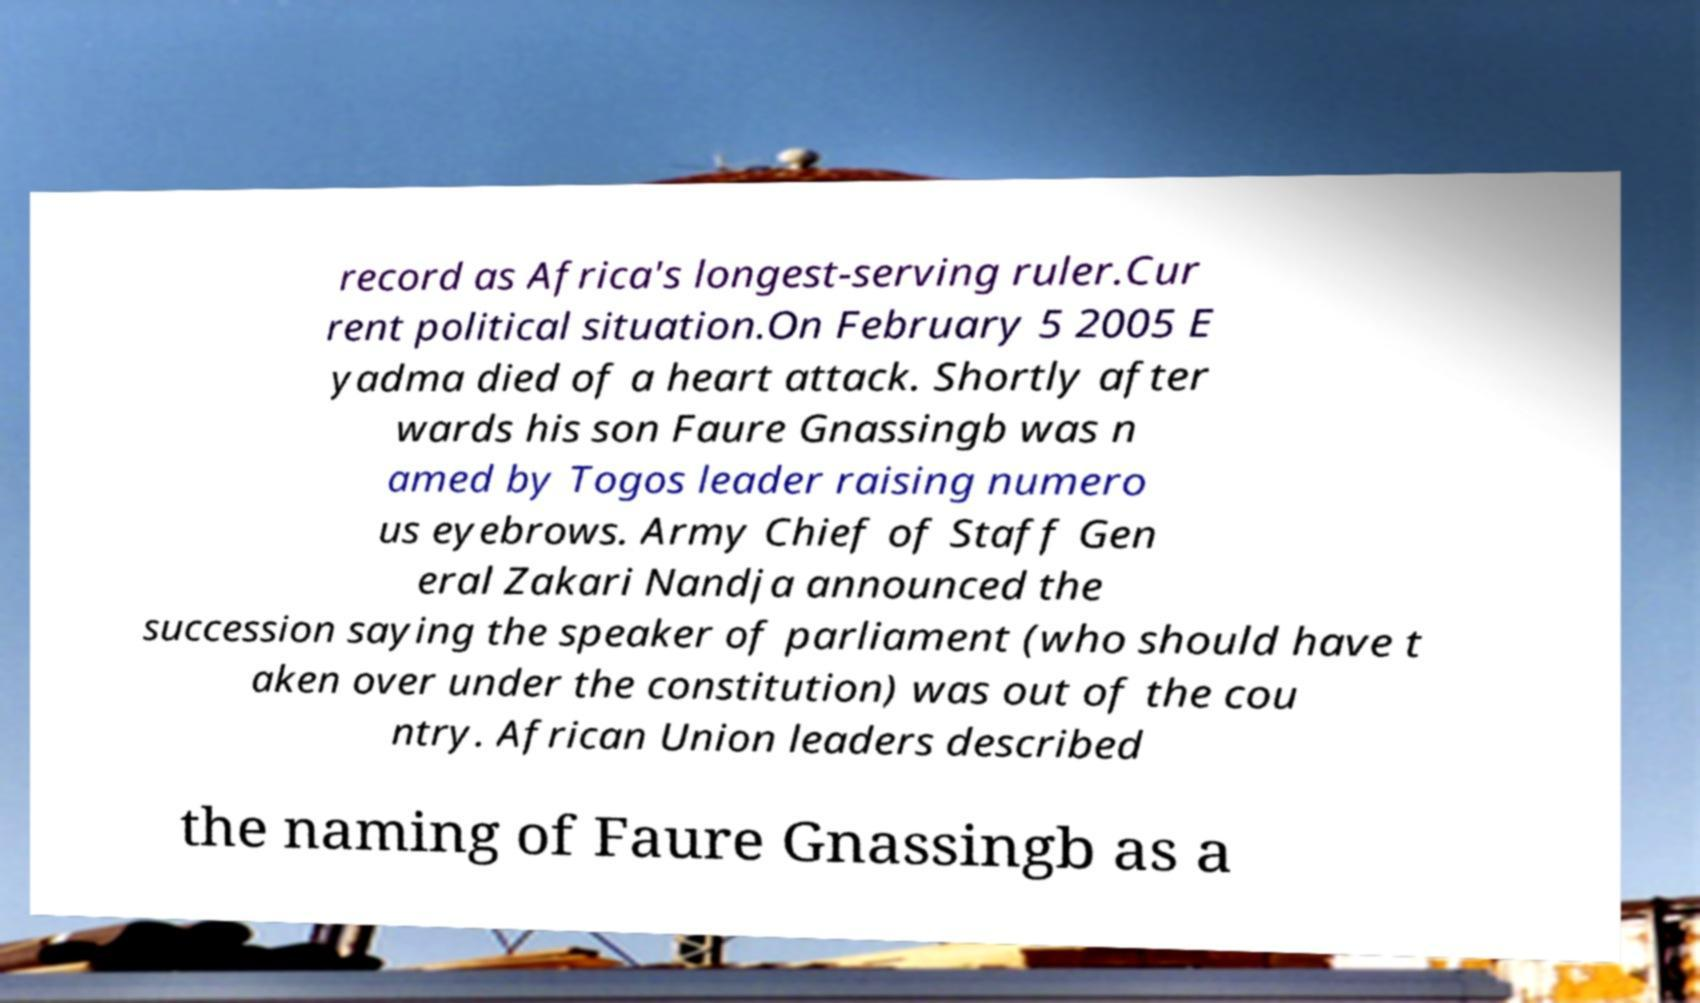I need the written content from this picture converted into text. Can you do that? record as Africa's longest-serving ruler.Cur rent political situation.On February 5 2005 E yadma died of a heart attack. Shortly after wards his son Faure Gnassingb was n amed by Togos leader raising numero us eyebrows. Army Chief of Staff Gen eral Zakari Nandja announced the succession saying the speaker of parliament (who should have t aken over under the constitution) was out of the cou ntry. African Union leaders described the naming of Faure Gnassingb as a 